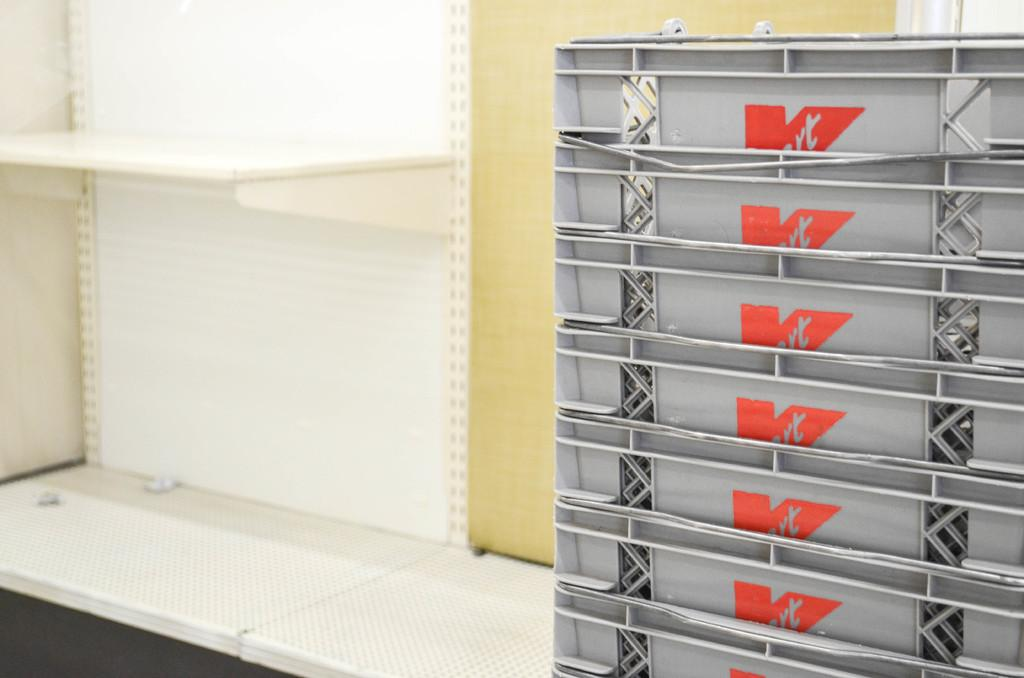<image>
Create a compact narrative representing the image presented. A collection of gray plastic Kmart bins are stacked together. 